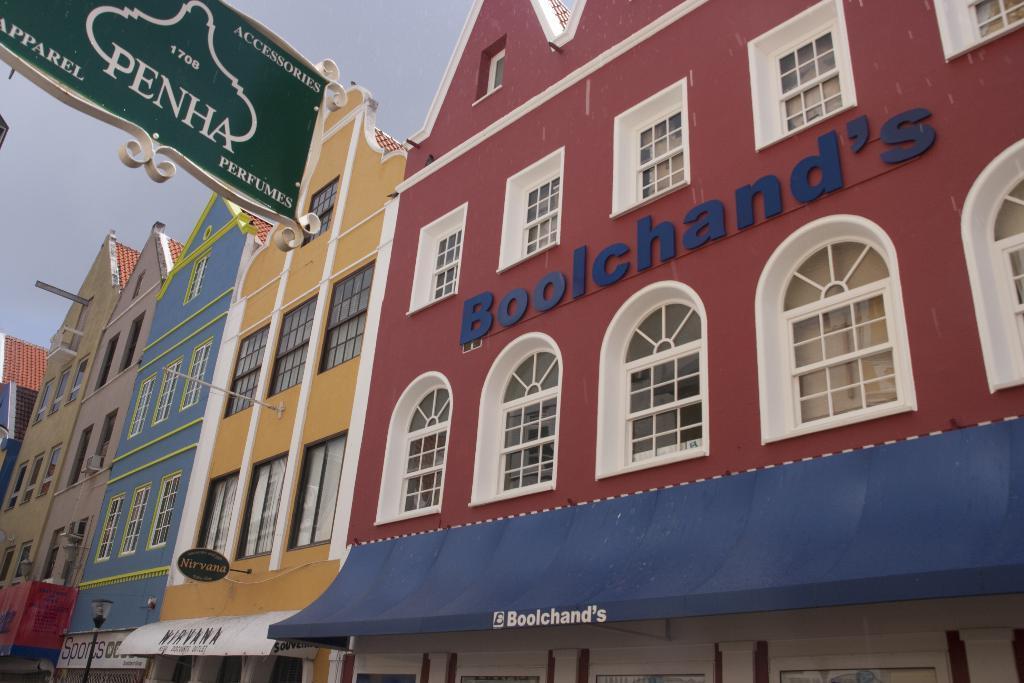Could you give a brief overview of what you see in this image? In the image I can see the building and glass windows. There is a hoarding board on the top left side of the image. I can see a decorative light pole on the bottom left side. 